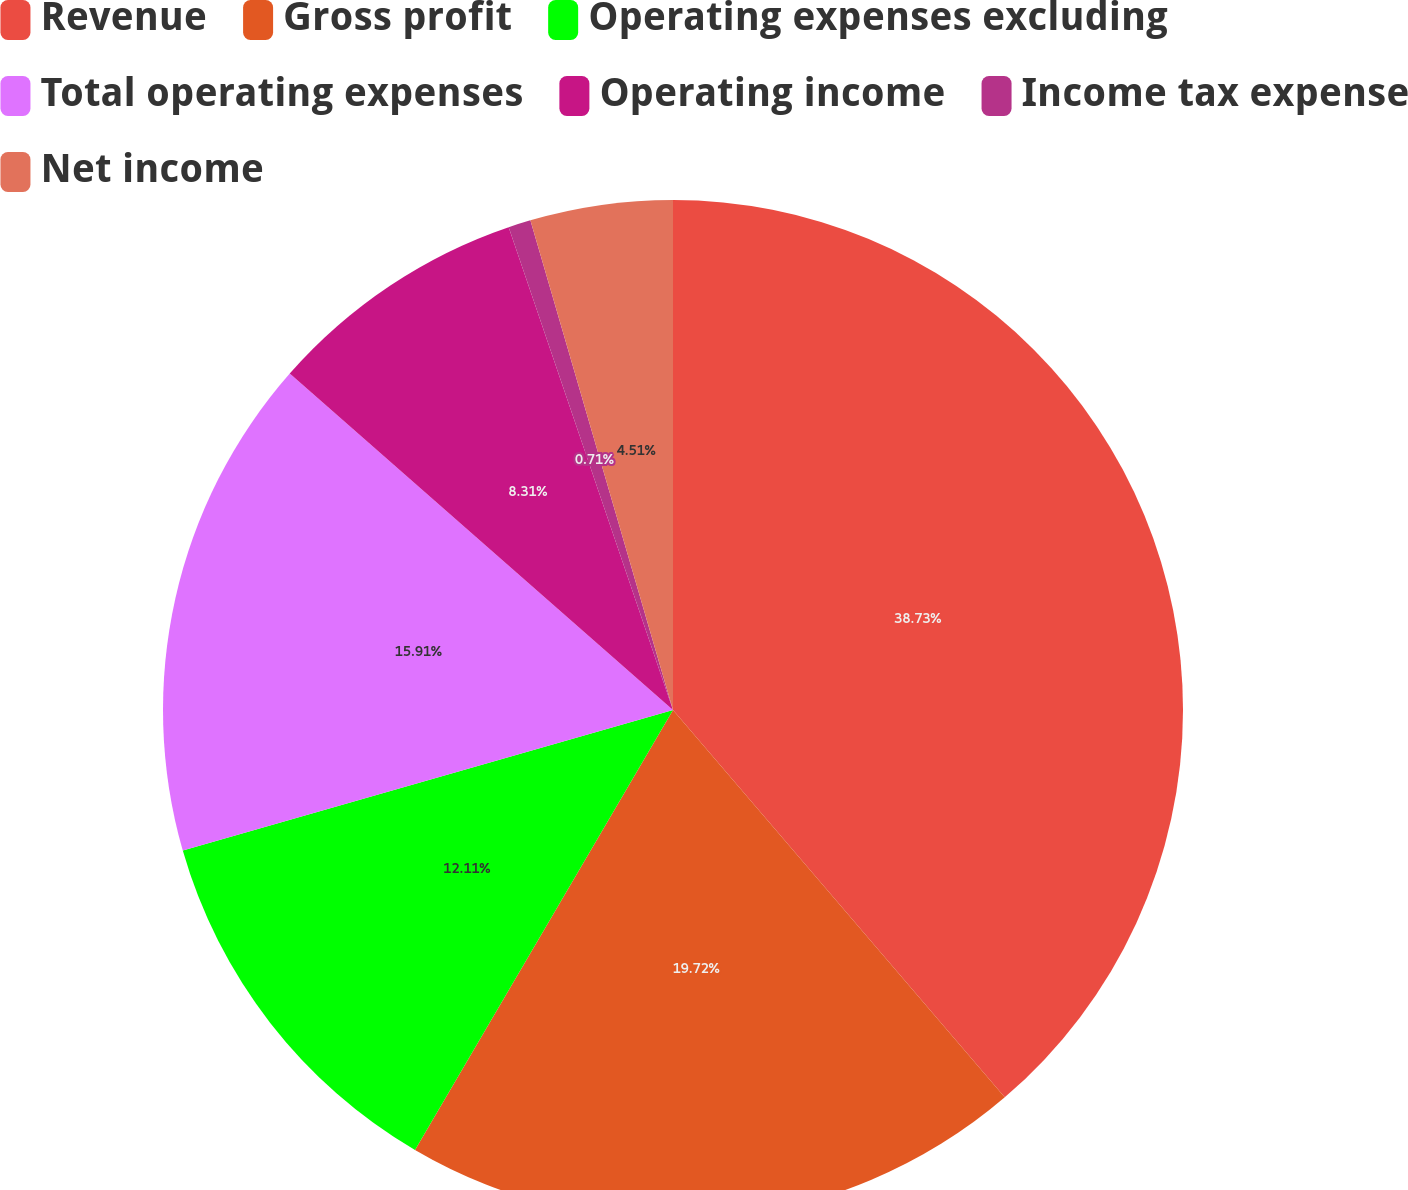<chart> <loc_0><loc_0><loc_500><loc_500><pie_chart><fcel>Revenue<fcel>Gross profit<fcel>Operating expenses excluding<fcel>Total operating expenses<fcel>Operating income<fcel>Income tax expense<fcel>Net income<nl><fcel>38.72%<fcel>19.71%<fcel>12.11%<fcel>15.91%<fcel>8.31%<fcel>0.71%<fcel>4.51%<nl></chart> 